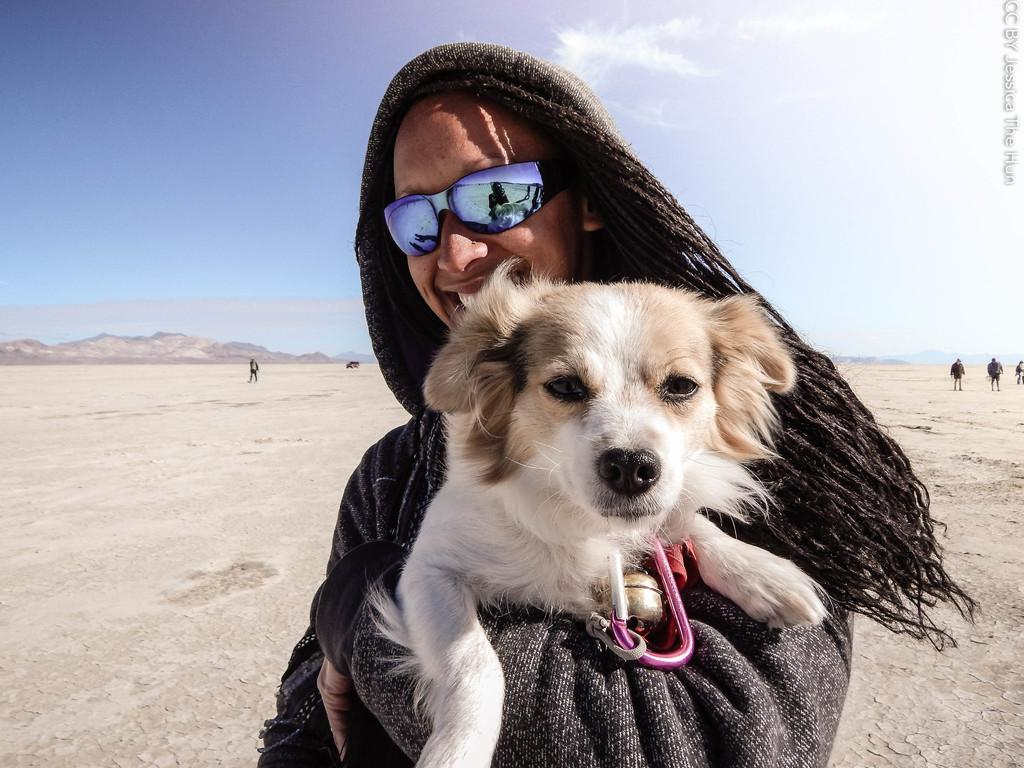What is the person in the image holding? The person is holding a dog in the image. What are the people in the image doing? The people are walking to the right in the image. What can be seen to the left in the image? There is a rock to the left in the image. What is visible in the background of the image? The sky is visible in the background of the image. What type of cloth is being used to cover the room in the image? There is no cloth or room present in the image. 